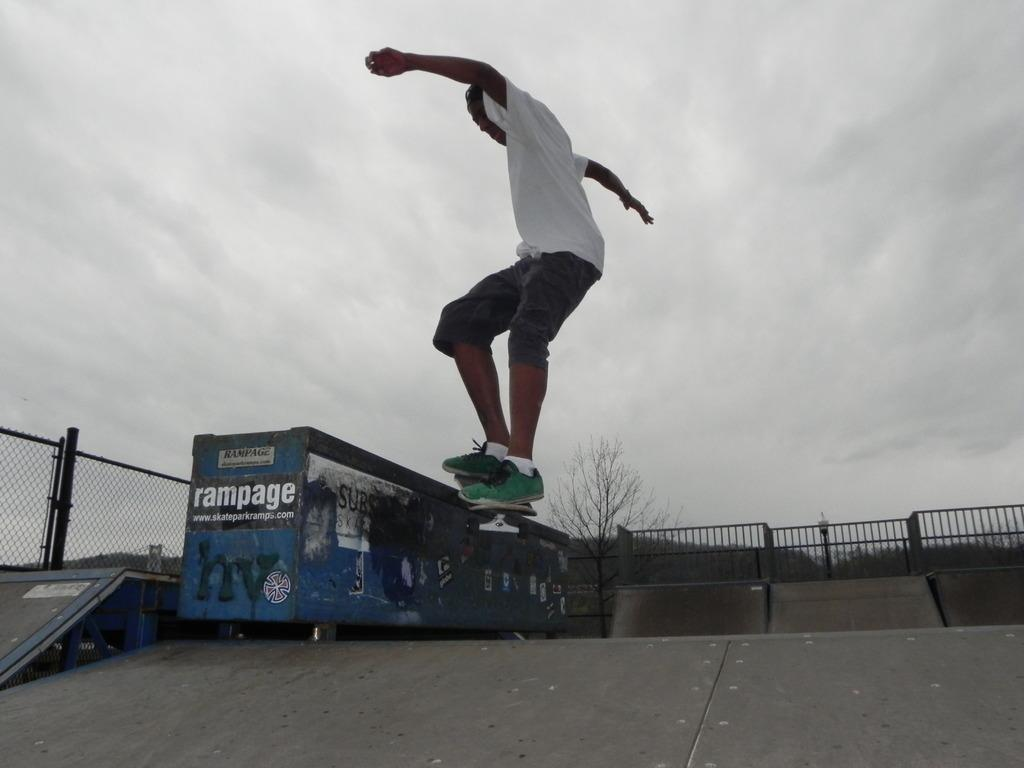What is the main subject of the image? The main subject of the image is a man. What is the man doing in the image? The man is skating with a skateboard in the image. Where is the man skating? The man is skating in a skate park. What is the boundary of the skate park? The skate park is surrounded by fencing. What can be seen in the background of the image? There is a tree and a cloudy sky in the background of the image. What book is the man reading while skating in the image? There is no book or reading activity present in the image; the man is skating with a skateboard. What type of tank is visible in the background of the image? There is no tank present in the image; the background features a tree and a cloudy sky. 